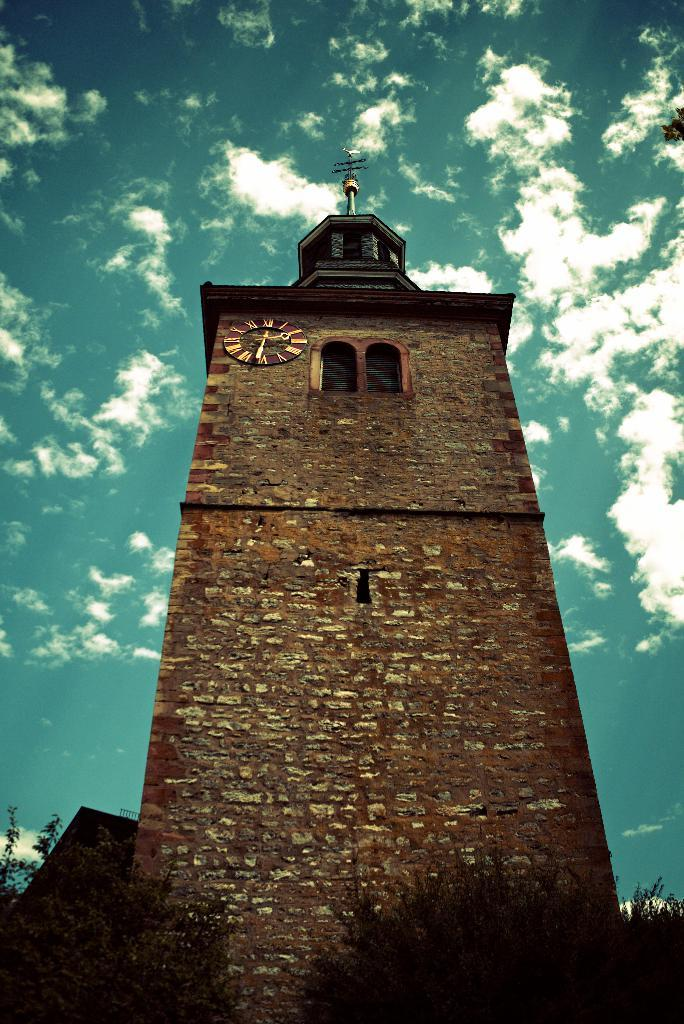What is the main subject in the center of the image? There is a brick structure in the center of the image. What can be seen at the bottom of the image? There are trees at the bottom of the image. What is visible in the background of the image? The sky is visible in the background of the image. How many pies are placed on top of the hat in the image? There is no hat or pies present in the image. 